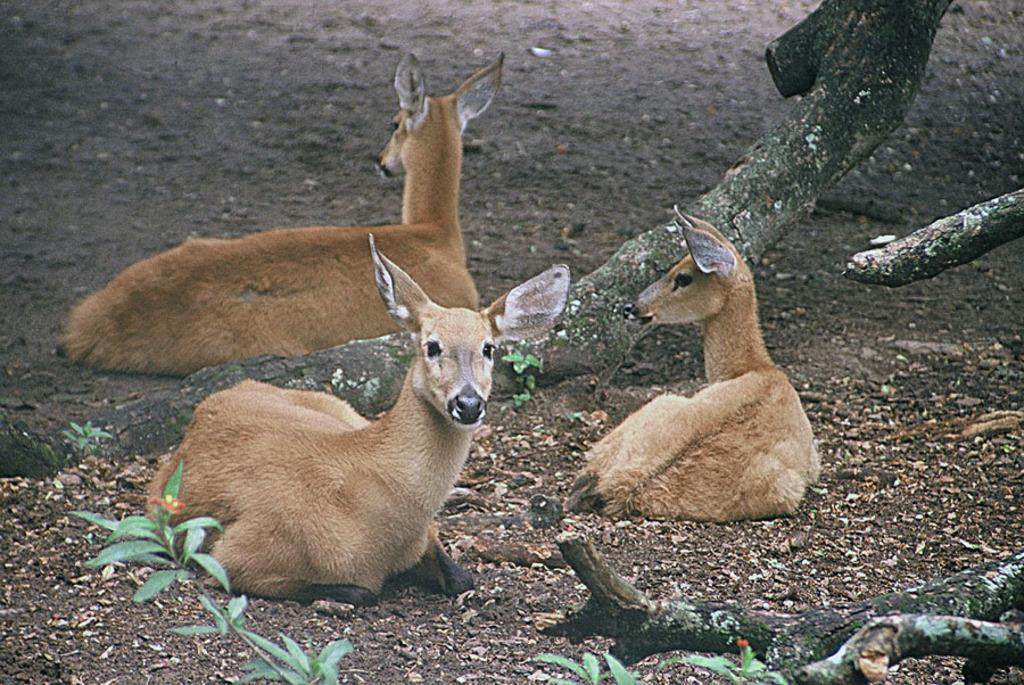What animals are in the center of the image? There are roe deer in the center of the image. What position are the roe deer in? The roe deer are sitting on the ground. What can be seen in the background of the image? There are trees and saw dust in the background of the image. What type of payment is being made to the queen in the image? There is no payment or queen present in the image; it features roe deer sitting on the ground with trees and saw dust in the background. 